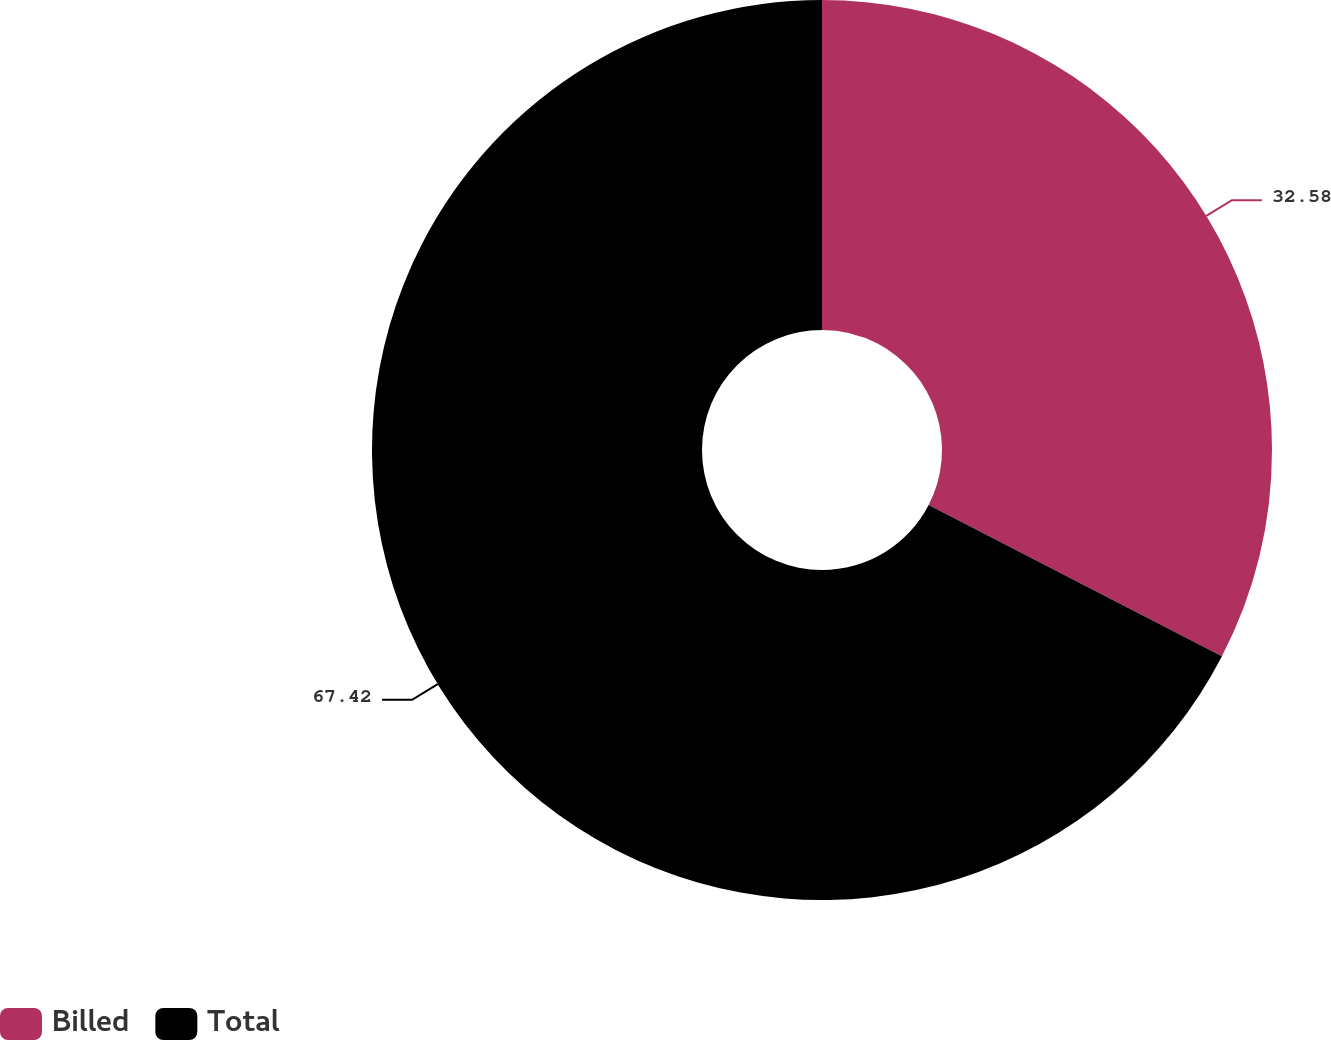<chart> <loc_0><loc_0><loc_500><loc_500><pie_chart><fcel>Billed<fcel>Total<nl><fcel>32.58%<fcel>67.42%<nl></chart> 